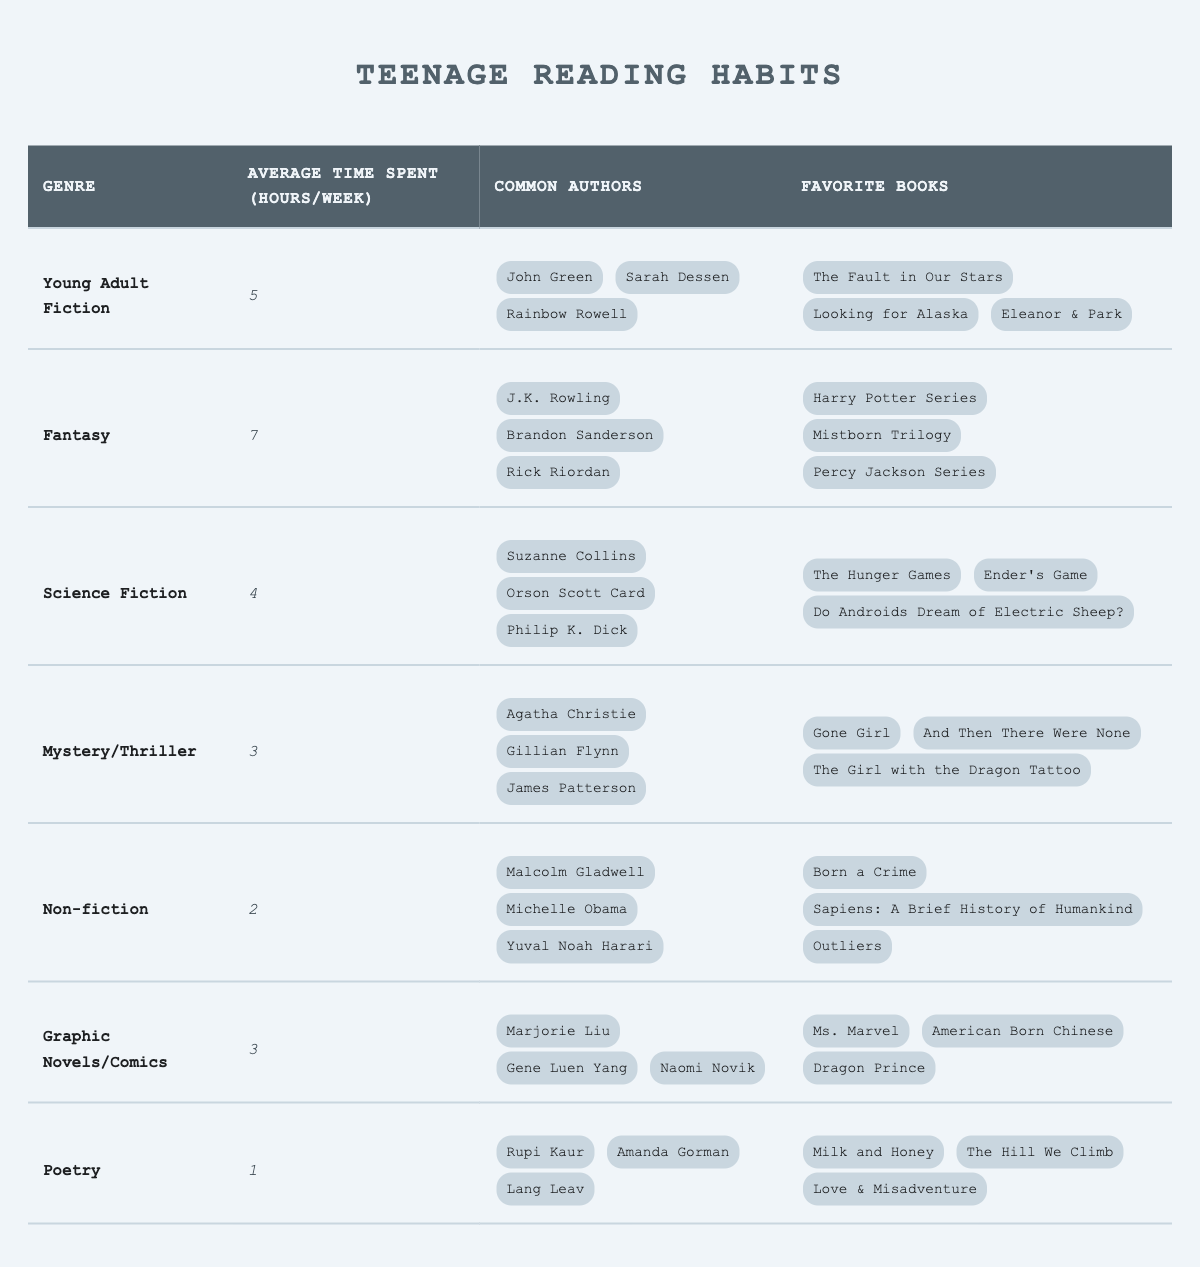What is the average time spent reading Fantasy books per week? According to the table, the average time spent reading Fantasy books is listed as 7 hours per week.
Answer: 7 Who are three common authors in the Young Adult Fiction genre? The table lists common authors for Young Adult Fiction as John Green, Sarah Dessen, and Rainbow Rowell.
Answer: John Green, Sarah Dessen, Rainbow Rowell Which genre has the least average time spent reading per week? By comparing the average time spent per genre, Poetry has the least at 1 hour per week.
Answer: Poetry How much more time is spent on average reading Fantasy than Non-fiction? The average time spent reading Fantasy is 7 hours, and for Non-fiction, it's 2 hours. The difference is 7 - 2 = 5 hours.
Answer: 5 hours Is it true that the common authors of the Mystery/Thriller genre include Agatha Christie? The table shows that Agatha Christie is indeed listed as a common author in the Mystery/Thriller genre.
Answer: Yes What is the total average reading time for all genres listed in the table? The average reading times for each genre are summed up: 5 + 7 + 4 + 3 + 2 + 3 + 1 = 25 hours. Therefore, the total average reading time for all genres is 25 hours.
Answer: 25 hours Which genre has more average reading time: Graphic Novels/Comics or Mystery/Thriller? Graphic Novels/Comics has an average time of 3 hours, while Mystery/Thriller has 3 hours as well. Since both are equal, neither has more average reading time.
Answer: They are equal What is the favorite book listed under the Science Fiction genre? The table shows three favorite books for Science Fiction, one of which is "The Hunger Games."
Answer: The Hunger Games How many genres have an average time spent of 3 hours or less? The genres with 3 hours or less are Mystery/Thriller (3), Non-fiction (2), Poetry (1). That's a total of 3 genres.
Answer: 3 genres If a teenager spent 2 hours reading Non-fiction and 5 hours reading Young Adult Fiction in a week, how many total hours did they dedicate to these genres? To find the total, add the hours spent on each genre: 2 hours (Non-fiction) + 5 hours (Young Adult Fiction) = 7 hours.
Answer: 7 hours 